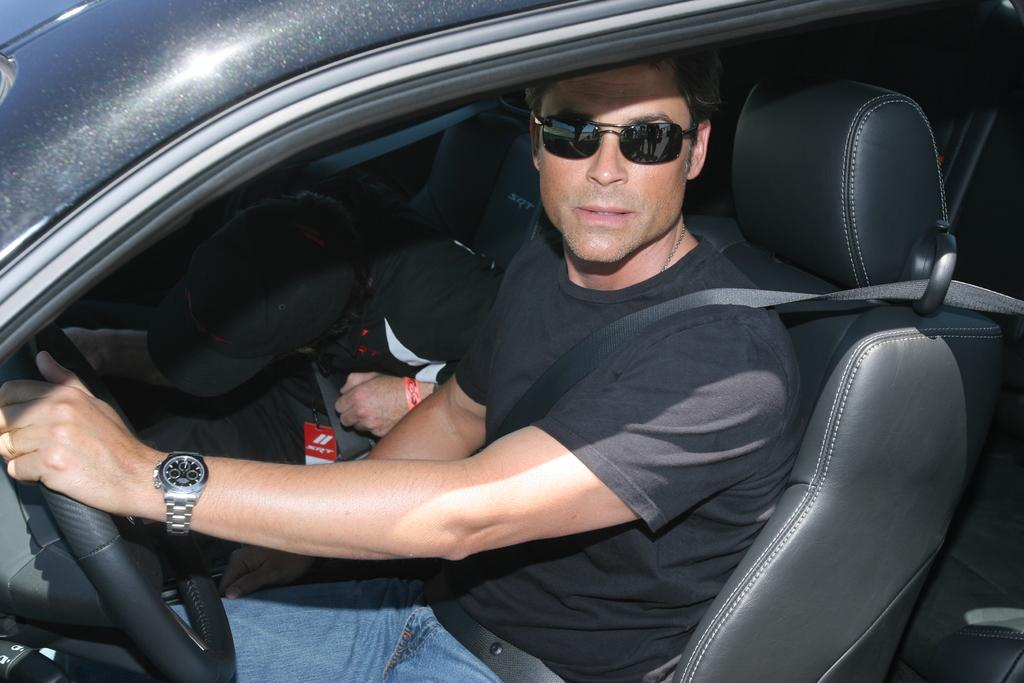What is the person doing in the image? The person is sitting in a car. What is the person holding in the image? The person is holding a car steering wheel. What accessory is the person wearing on their wrist? The person is wearing a watch. What is the person wearing to help with vision? The person is wearing spectacles. What safety feature is the person using in the car? The person is wearing a car seat belt. What is the person wearing on their upper body? The person is wearing a black shirt with colorful elements. What force is being applied by the person to the car's back in the image? There is no indication in the image that the person is applying any force to the car's back. 